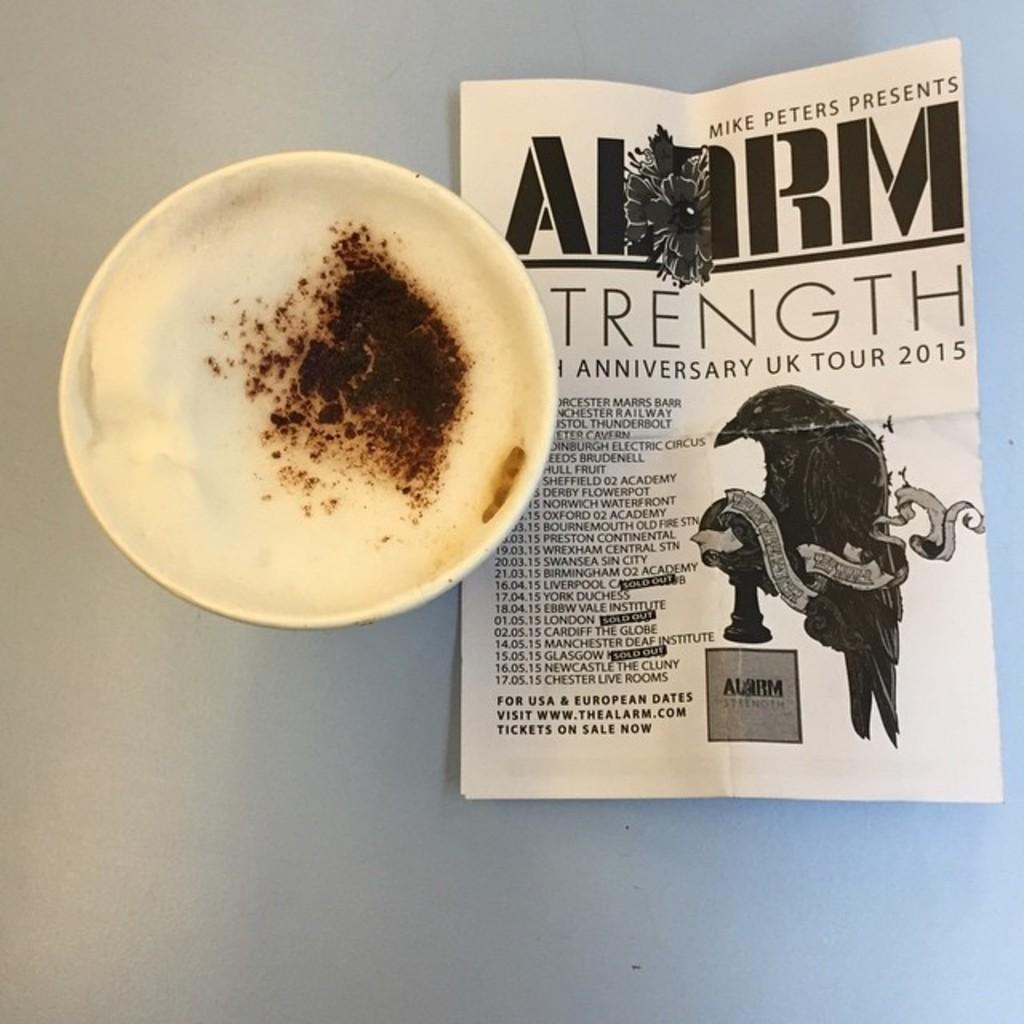What is in the cup that is visible in the image? There is a cup of coffee in the image. What else can be seen in the image besides the cup of coffee? There is a paper on an object in the image. What type of rhythm can be heard coming from the bushes in the image? There are no bushes or any sounds mentioned in the image, so it's not possible to determine what rhythm might be heard. 